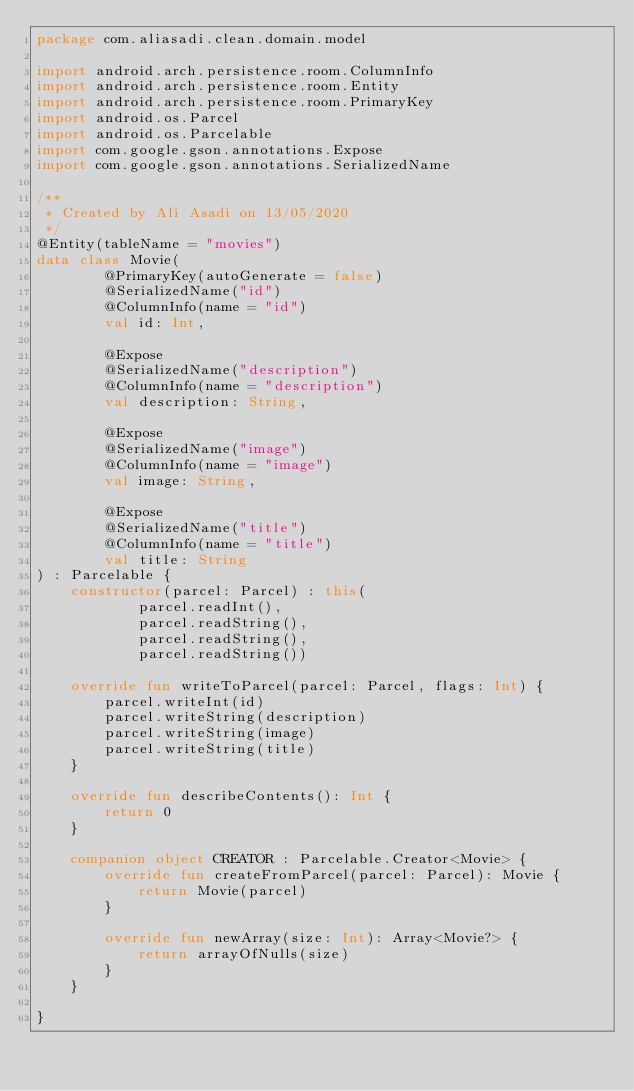Convert code to text. <code><loc_0><loc_0><loc_500><loc_500><_Kotlin_>package com.aliasadi.clean.domain.model

import android.arch.persistence.room.ColumnInfo
import android.arch.persistence.room.Entity
import android.arch.persistence.room.PrimaryKey
import android.os.Parcel
import android.os.Parcelable
import com.google.gson.annotations.Expose
import com.google.gson.annotations.SerializedName

/**
 * Created by Ali Asadi on 13/05/2020
 */
@Entity(tableName = "movies")
data class Movie(
        @PrimaryKey(autoGenerate = false)
        @SerializedName("id")
        @ColumnInfo(name = "id")
        val id: Int,

        @Expose
        @SerializedName("description")
        @ColumnInfo(name = "description")
        val description: String,

        @Expose
        @SerializedName("image")
        @ColumnInfo(name = "image")
        val image: String,

        @Expose
        @SerializedName("title")
        @ColumnInfo(name = "title")
        val title: String
) : Parcelable {
    constructor(parcel: Parcel) : this(
            parcel.readInt(),
            parcel.readString(),
            parcel.readString(),
            parcel.readString())

    override fun writeToParcel(parcel: Parcel, flags: Int) {
        parcel.writeInt(id)
        parcel.writeString(description)
        parcel.writeString(image)
        parcel.writeString(title)
    }

    override fun describeContents(): Int {
        return 0
    }

    companion object CREATOR : Parcelable.Creator<Movie> {
        override fun createFromParcel(parcel: Parcel): Movie {
            return Movie(parcel)
        }

        override fun newArray(size: Int): Array<Movie?> {
            return arrayOfNulls(size)
        }
    }

}</code> 